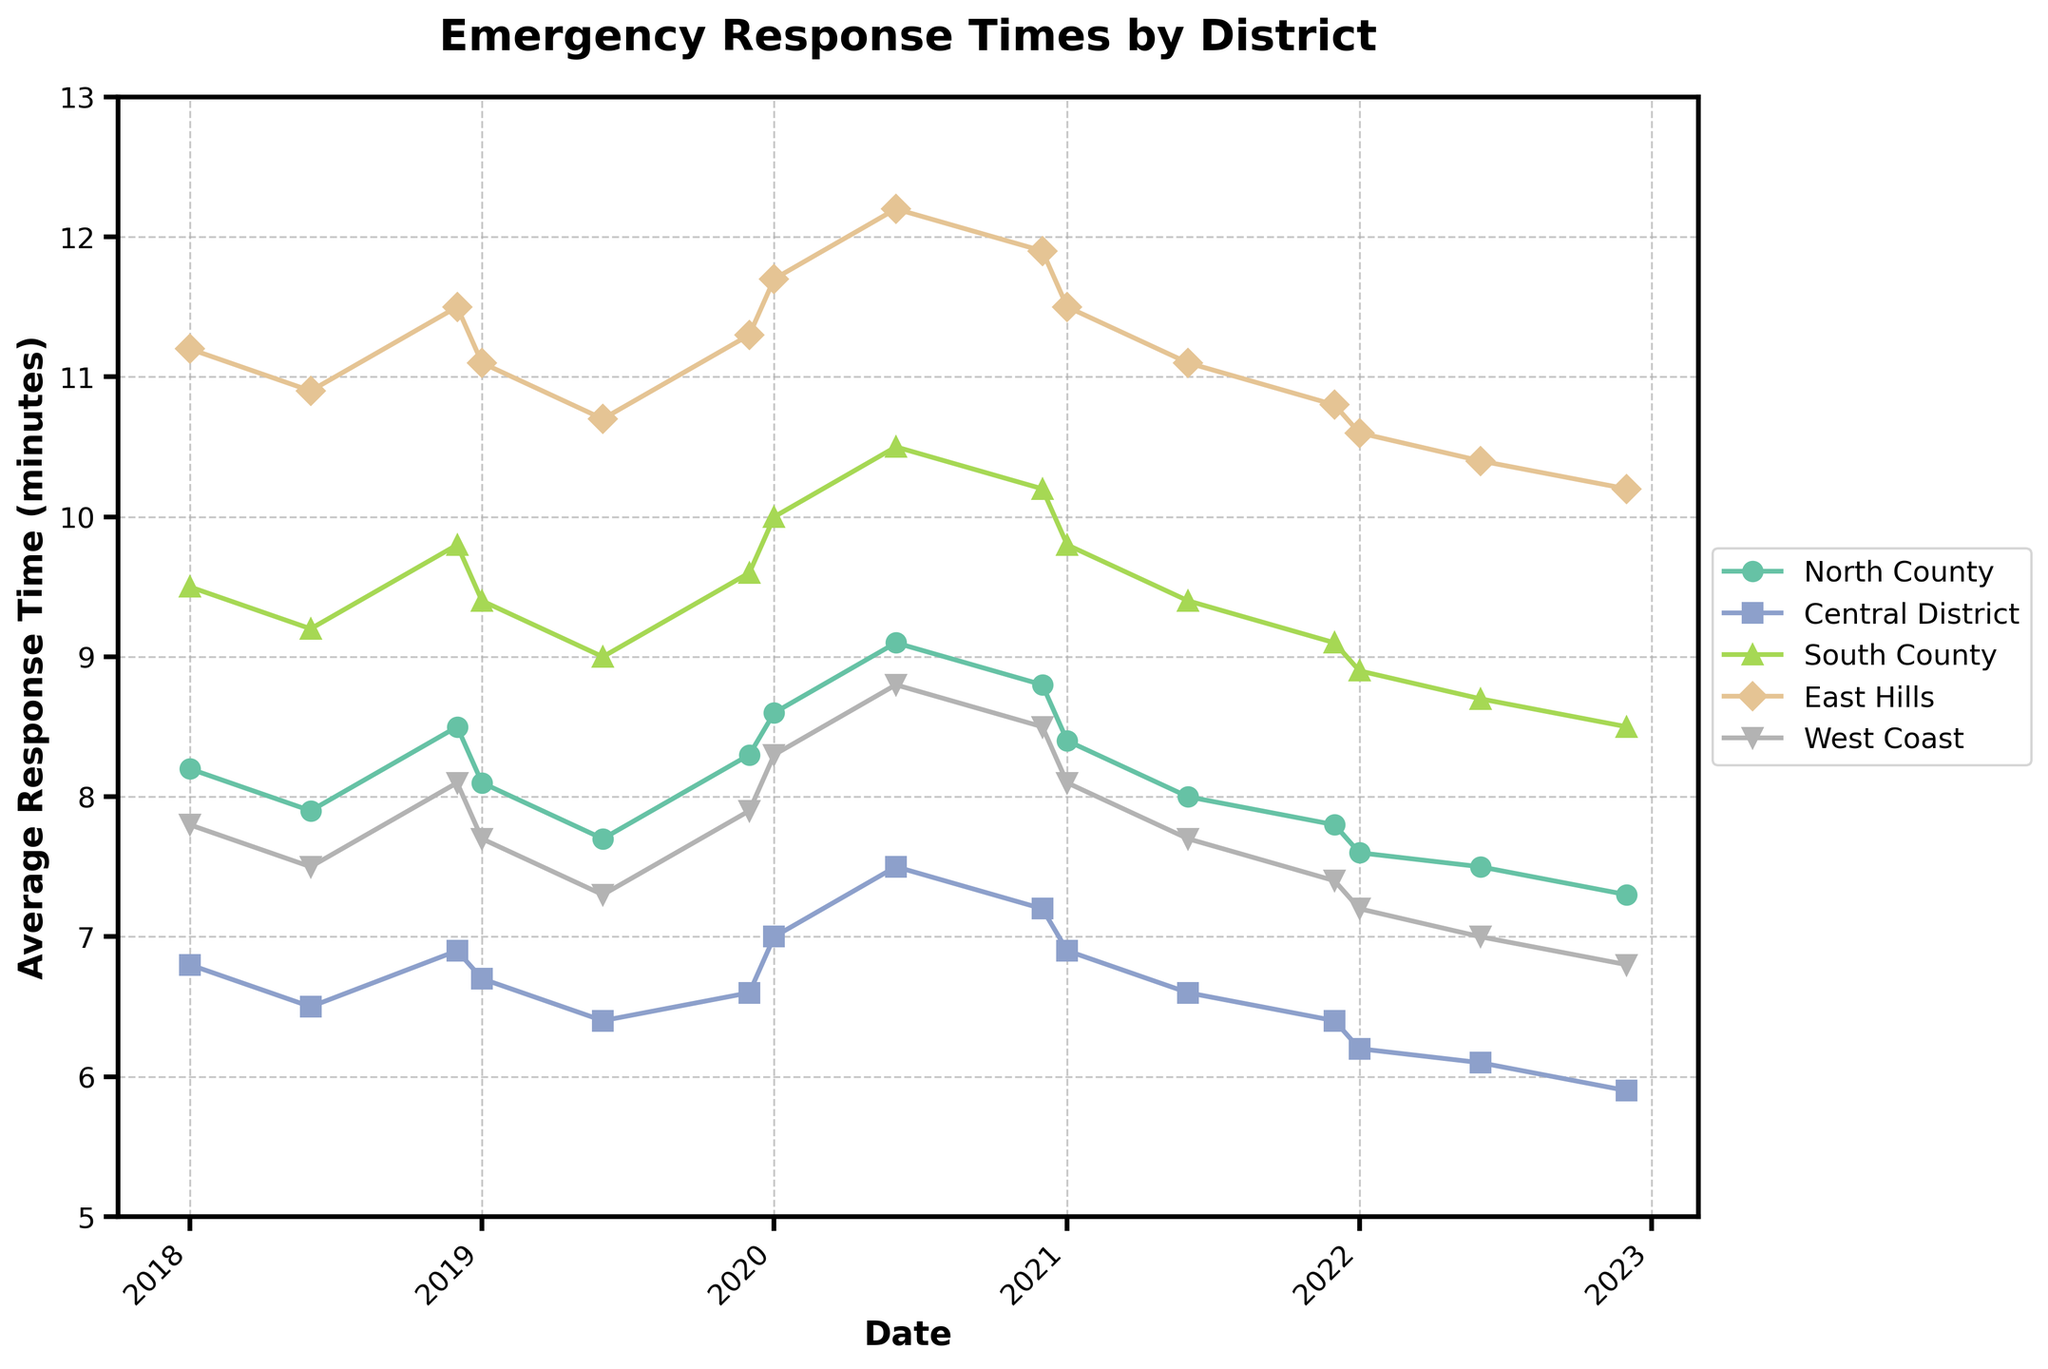What is the trend in average response times in the North County from 2020 to 2022? First, isolate the data points from 2020 to 2022 for North County, then check the line plot connecting these points. In 2020, the average response times were 8.6, 9.1, and 8.8 in January, June, and December, respectively. In 2021, the values were 8.4, 8.0, and 7.8, indicating a downward trend. In 2022, the values continued to decrease to 7.6, 7.5, and 7.3. The overall trend is a decrease in response times.
Answer: Decreasing trend Which district had the highest average response time in December 2022? Look at the data points for December 2022 across all districts. The values are North County (7.3), Central District (5.9), South County (8.5), East Hills (10.2), and West Coast (6.8). The highest response time in December 2022 is in East Hills.
Answer: East Hills Compare the response times of the Central District and South County in January 2020. Which district had a faster response time, and by how much? In January 2020, Central District has an average response time of 7.0 minutes, and South County has an average response time of 10.0 minutes. Subtract the Central District's time from South County's time: 10.0 - 7.0 = 3.0. Central District had a faster response time by 3.0 minutes.
Answer: Central District, 3.0 minutes By how much did the response time change in East Hills from June to December 2020? Look at the response times for East Hills in June 2020 (12.2 minutes) and December 2020 (11.9 minutes). Subtract the December value from the June value: 12.2 - 11.9 = 0.3. There was a decrease of 0.3 minutes.
Answer: Decrease by 0.3 minutes What pattern can be observed in the response times for the Central District over the period? Observe the line plot for Central District from 2018 to 2022. The response times start at 6.8 in January 2018 and gradually decrease with minor fluctuations over the years, ending at 5.9 in December 2022, indicating an overall downward trend.
Answer: Decreasing trend During which month and year did North County experience the highest average response time? Review the plot for North County and identify the peak point. North County had the highest average response time in June 2020, at 9.1 minutes.
Answer: June 2020 What is the difference in response time trends between South County and West Coast from 2018 to 2022? Compare the line plots of South County and West Coast. South County starts at 9.5 in January 2018 and shows a slight increasing trend until 2020, peaking at 10.5 in June 2020, then gradually decreases to 8.5 in December 2022. West Coast starts at 7.8 in January 2018, peaks at 8.8 in June 2020, and steadily decreases to 6.8 in December 2022. Both experience a peak around mid-2020, followed by gradual improvement, but South County's values are consistently higher.
Answer: Both show peaks in 2020; South County values are higher Which two districts had the closest response times in January 2022? Check the average response times for January 2022 across all districts. The values are North County (7.6), Central District (6.2), South County (8.9), East Hills (10.6), and West Coast (7.2). North County and West Coast have the closest response times, differing by 0.4 minutes.
Answer: North County and West Coast 